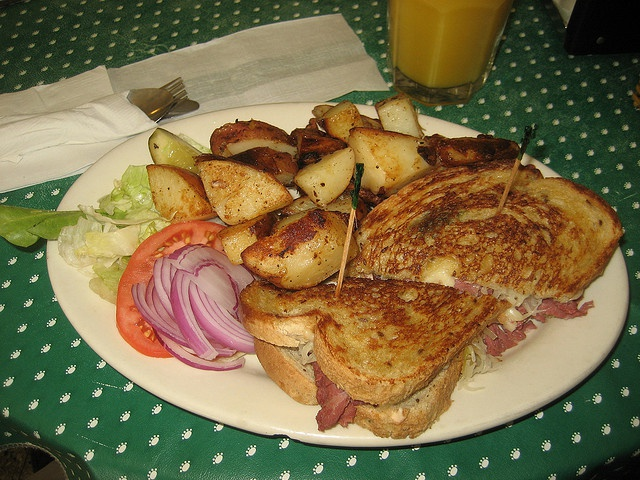Describe the objects in this image and their specific colors. I can see dining table in black, darkgreen, olive, and tan tones, sandwich in darkgreen, brown, tan, and maroon tones, sandwich in darkgreen, olive, maroon, and tan tones, cup in darkgreen, olive, and black tones, and spoon in darkgreen, olive, black, and gray tones in this image. 